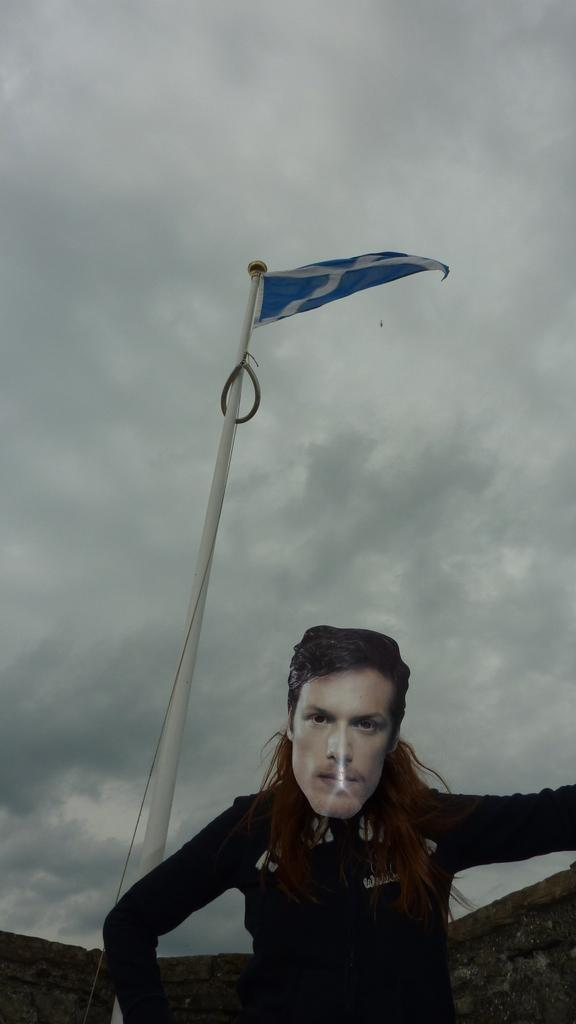Who or what is the main subject in the image? There is a person in the image. What is the object behind the person? There is a flag on a pole in the image, and it is behind the person. What type of barrier is visible in the image? There is a rock fence in the image. Where is the rock fence located in relation to the flag? The rock fence is behind the flag. What can be seen in the sky in the image? There are clouds visible in the sky. What color of paint is the person using in the image? There is no paint or painting activity present in the image. What type of work is the person doing in the image? The image does not provide information about the person's work or occupation. 